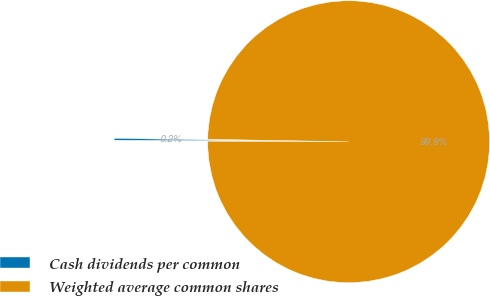<chart> <loc_0><loc_0><loc_500><loc_500><pie_chart><fcel>Cash dividends per common<fcel>Weighted average common shares<nl><fcel>0.21%<fcel>99.79%<nl></chart> 